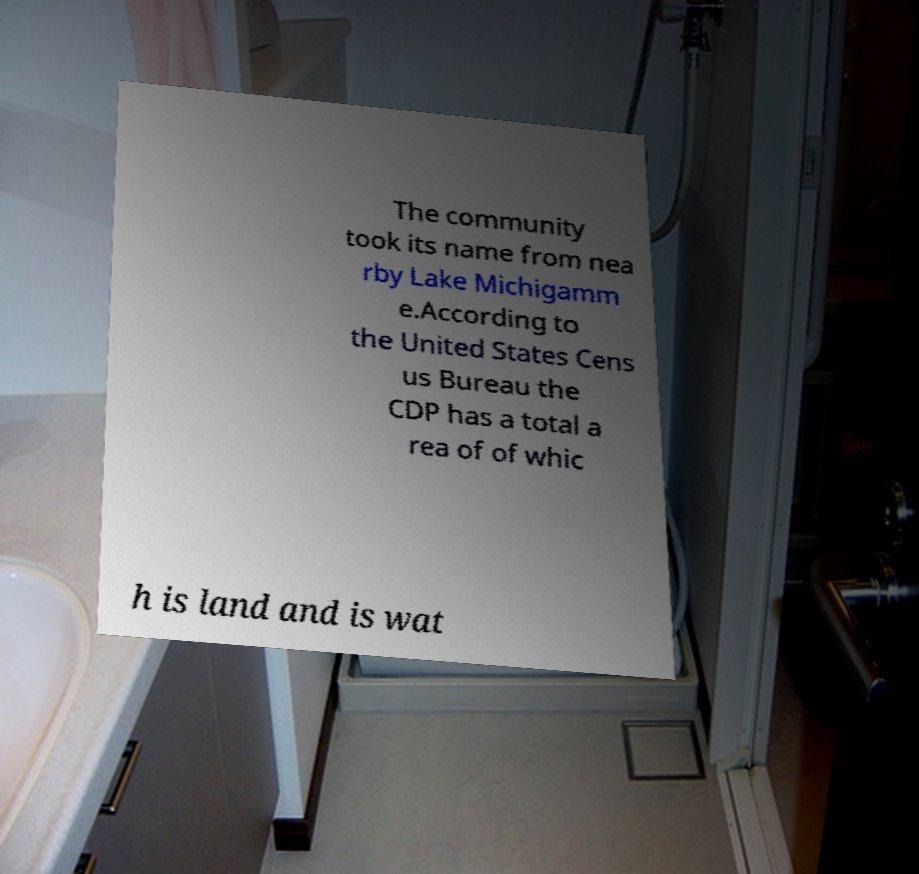Please identify and transcribe the text found in this image. The community took its name from nea rby Lake Michigamm e.According to the United States Cens us Bureau the CDP has a total a rea of of whic h is land and is wat 